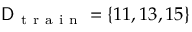<formula> <loc_0><loc_0><loc_500><loc_500>D _ { t r a i n } = \{ 1 1 , 1 3 , 1 5 \}</formula> 